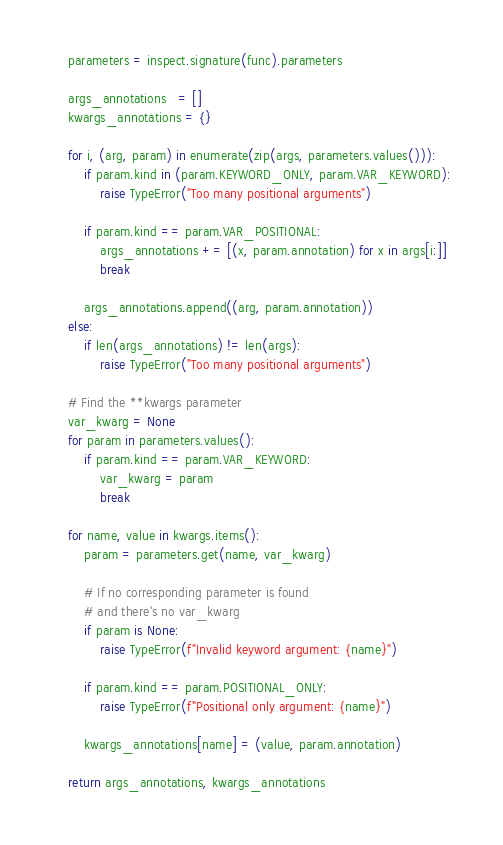<code> <loc_0><loc_0><loc_500><loc_500><_Python_>
    parameters = inspect.signature(func).parameters

    args_annotations   = []
    kwargs_annotations = {}

    for i, (arg, param) in enumerate(zip(args, parameters.values())):
        if param.kind in (param.KEYWORD_ONLY, param.VAR_KEYWORD):
            raise TypeError("Too many positional arguments")

        if param.kind == param.VAR_POSITIONAL:
            args_annotations += [(x, param.annotation) for x in args[i:]]
            break

        args_annotations.append((arg, param.annotation))
    else:
        if len(args_annotations) != len(args):
            raise TypeError("Too many positional arguments")

    # Find the **kwargs parameter
    var_kwarg = None
    for param in parameters.values():
        if param.kind == param.VAR_KEYWORD:
            var_kwarg = param
            break

    for name, value in kwargs.items():
        param = parameters.get(name, var_kwarg)

        # If no corresponding parameter is found
        # and there's no var_kwarg
        if param is None:
            raise TypeError(f"Invalid keyword argument: {name}")

        if param.kind == param.POSITIONAL_ONLY:
            raise TypeError(f"Positional only argument: {name}")

        kwargs_annotations[name] = (value, param.annotation)

    return args_annotations, kwargs_annotations
</code> 